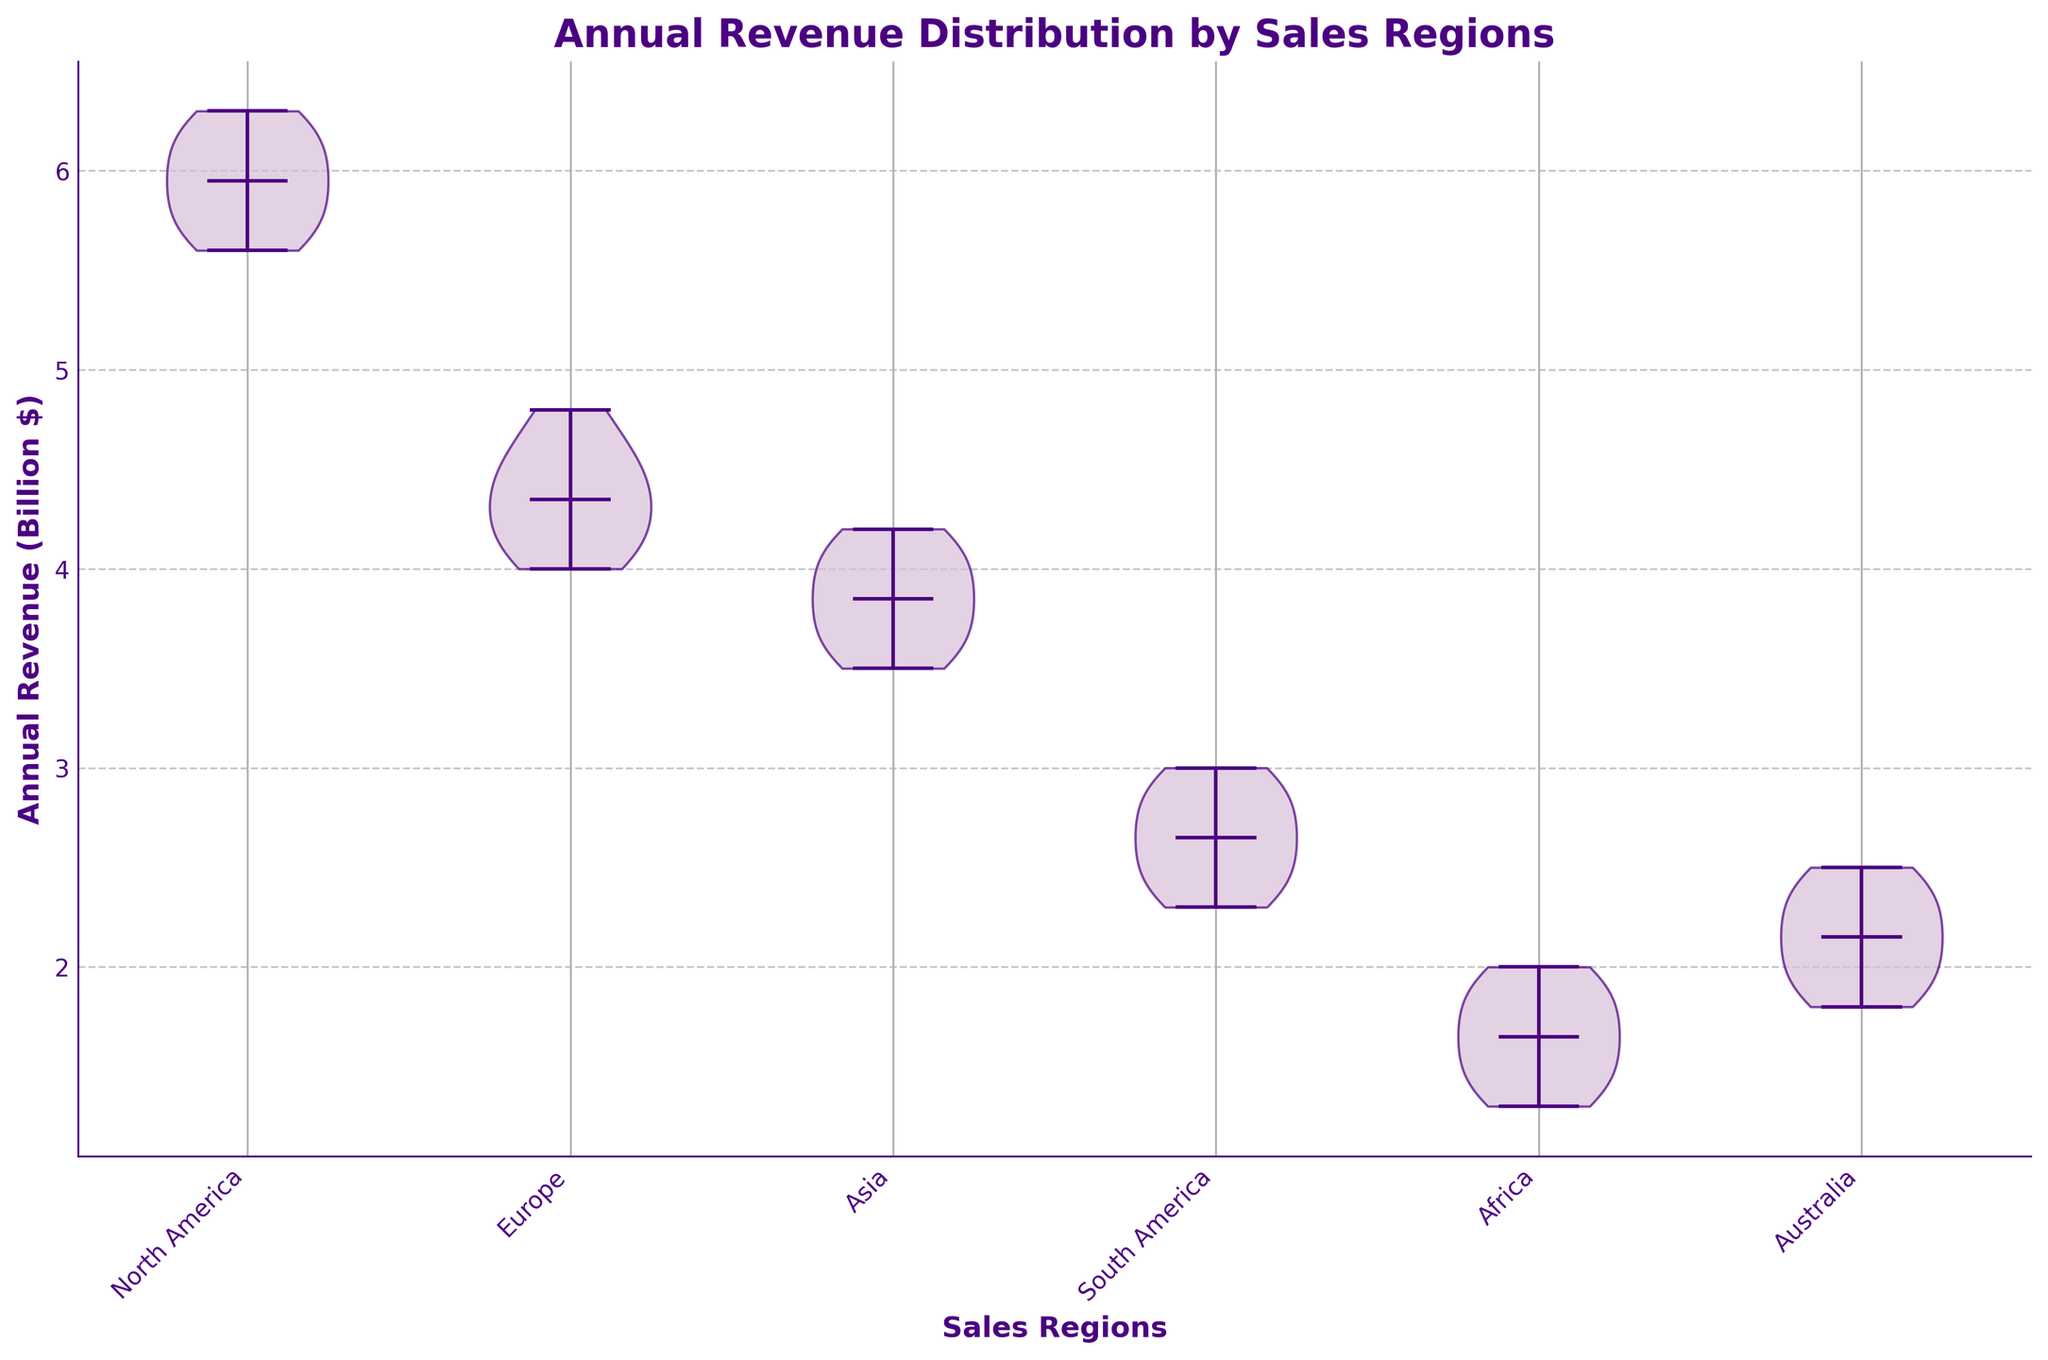What does the title of the diagram indicate? The title provides a clear representation of the data being visualized, which is about the distribution of annual revenue across different sales regions.
Answer: Annual Revenue Distribution by Sales Regions Which sales region has the highest median annual revenue? By observing the middle line (median) within each violin shape, we can identify North America as the region with the highest median annual revenue.
Answer: North America Comparing Europe and South America, which region shows a larger spread of annual revenue values? The spread of values is indicated by the width and range of the violin plot. Europe has a broader and higher violin shape compared to South America, indicating a larger spread of annual revenue values in Europe.
Answer: Europe What is the approximate range of annual revenue for the Africa region? To determine the range, look at the lowest and highest points of the violin plot for Africa. The annual revenue ranges approximately from 1.3 billion to 2.0 billion.
Answer: 1.3 billion to 2.0 billion Which region's annual revenue distribution is the most symmetric? A symmetric distribution will have a violin shape that is balanced on both sides. The Europe region shows a more symmetric violin shape compared to other regions.
Answer: Europe What is the median annual revenue for the Asia region? The median value is represented by the white dot in the center of the violin for each region. For Asia, this dot is situated around 3.8 billion.
Answer: 3.8 billion Among all regions, which one has the smallest spread in annual revenue? The region with the smallest spread will have the narrowest violin plot. Australia has the smallest spread, with annual revenue ranging approximately from 1.8 billion to 2.5 billion.
Answer: Australia How does the median annual revenue for North America compare to that of Australia? Observing the central white dots in both North America and Australia violin plots, it's clear that North America's median is considerably higher, around 6.0 billion, whereas Australia's median is around 2.2 billion.
Answer: North America’s median is higher If we were to compare only Africa and South America, which region exhibits greater variability in annual revenue? Variability is observed through the spread of the violin plot. Africa displays a wider spread compared to South America, indicating greater variability in annual revenue.
Answer: Africa What can be inferred about the distribution of annual revenue in the North America region? The wide, consistent spread of the violin plot from around 5.6 billion to 6.3 billion, combined with a central dense area, implies a relatively uniform distribution with no significant outliers.
Answer: Uniform distribution 